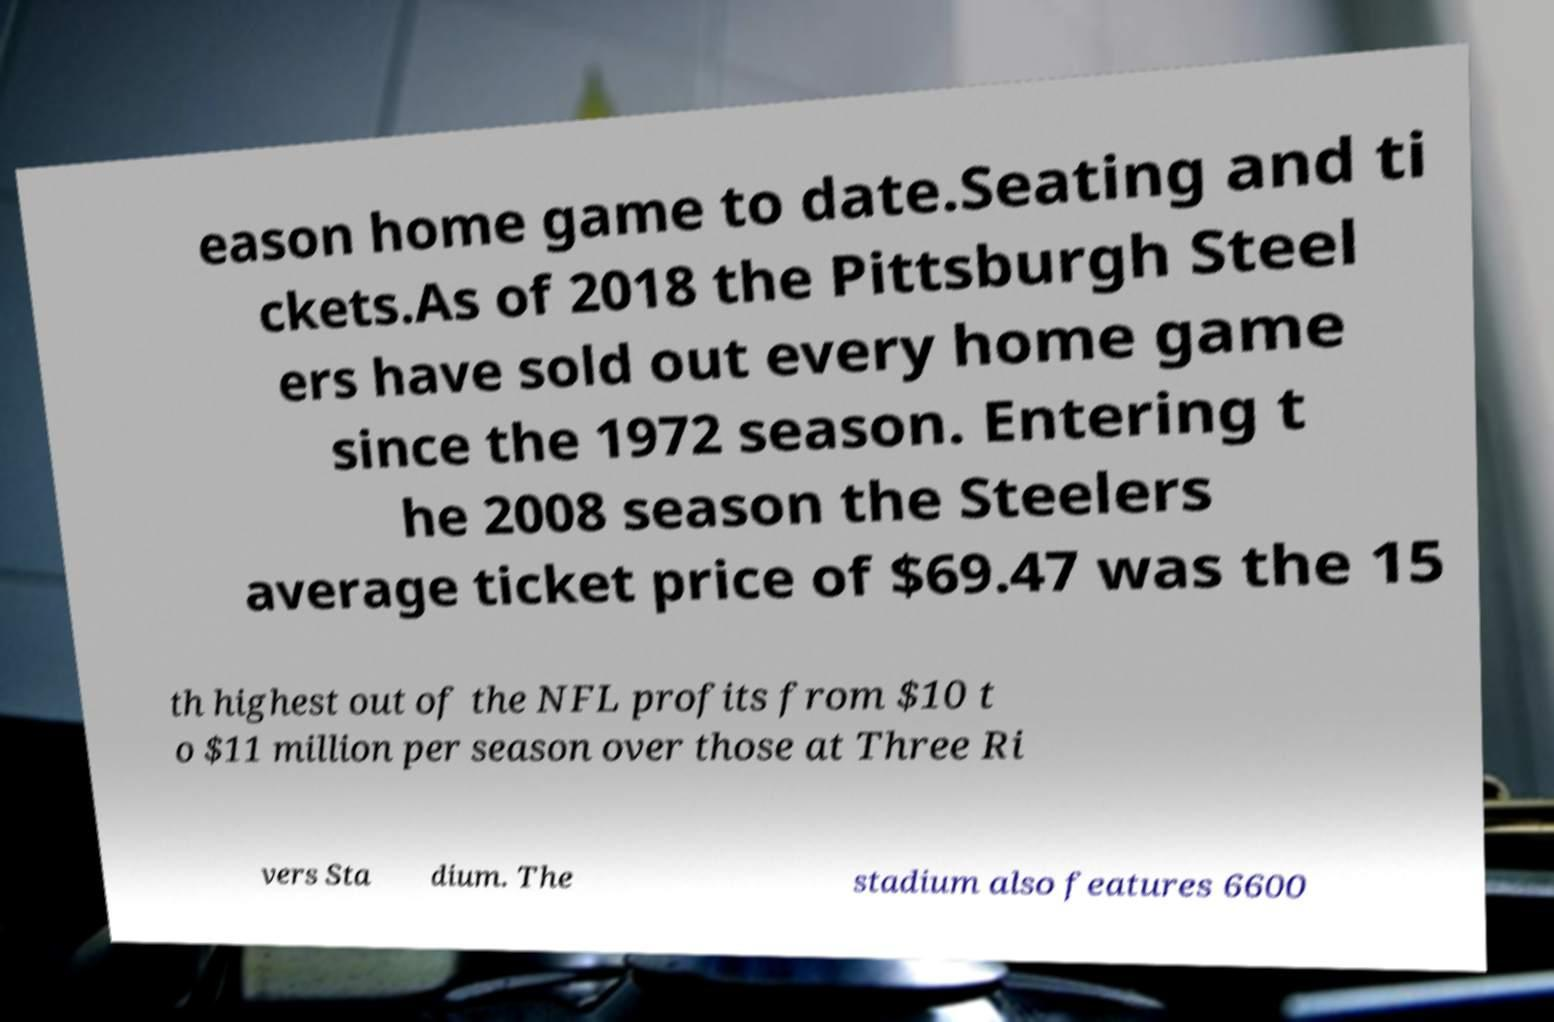Can you accurately transcribe the text from the provided image for me? eason home game to date.Seating and ti ckets.As of 2018 the Pittsburgh Steel ers have sold out every home game since the 1972 season. Entering t he 2008 season the Steelers average ticket price of $69.47 was the 15 th highest out of the NFL profits from $10 t o $11 million per season over those at Three Ri vers Sta dium. The stadium also features 6600 